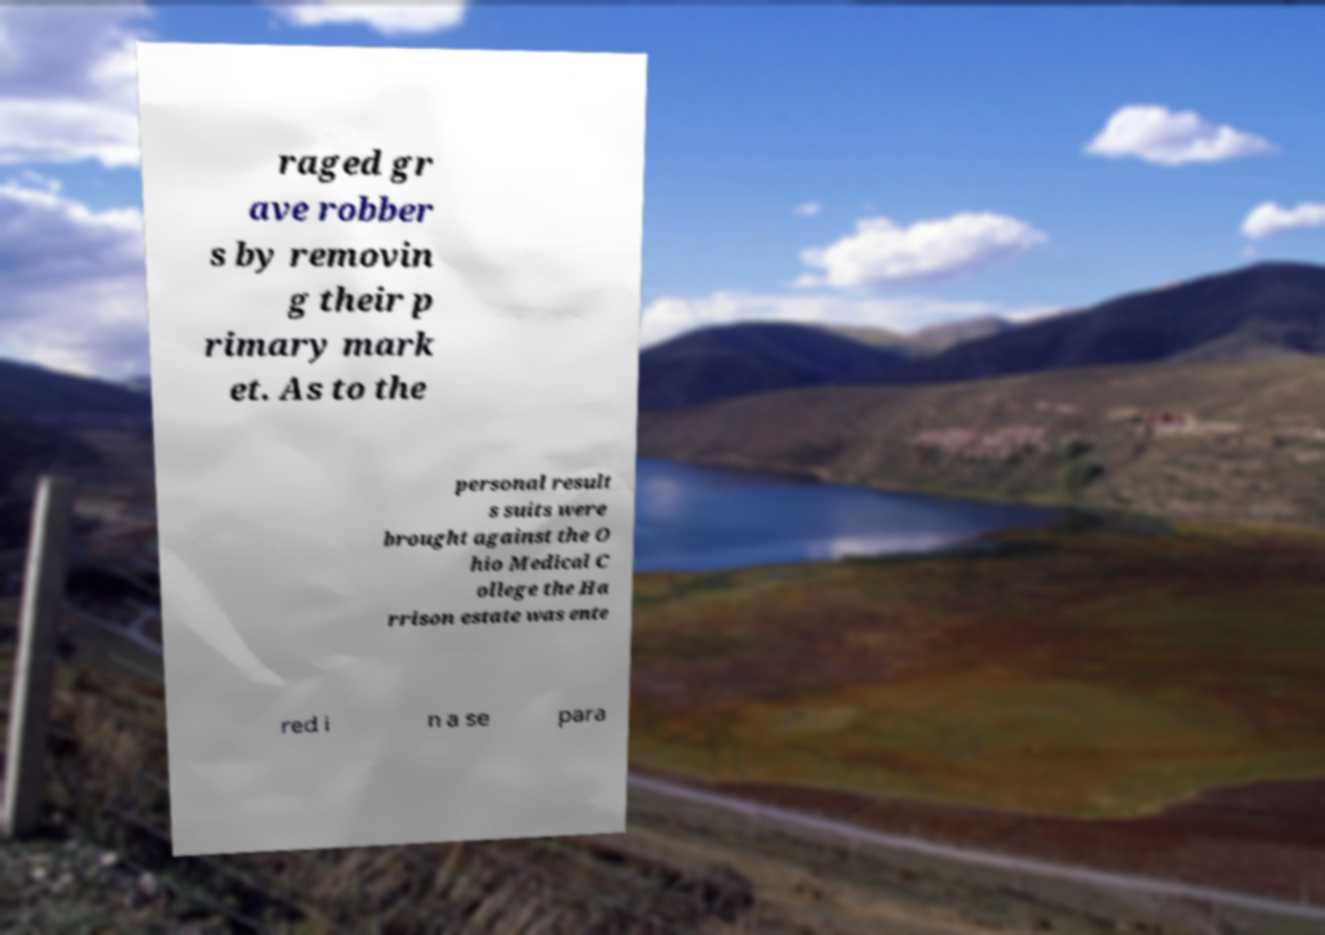Please identify and transcribe the text found in this image. raged gr ave robber s by removin g their p rimary mark et. As to the personal result s suits were brought against the O hio Medical C ollege the Ha rrison estate was ente red i n a se para 